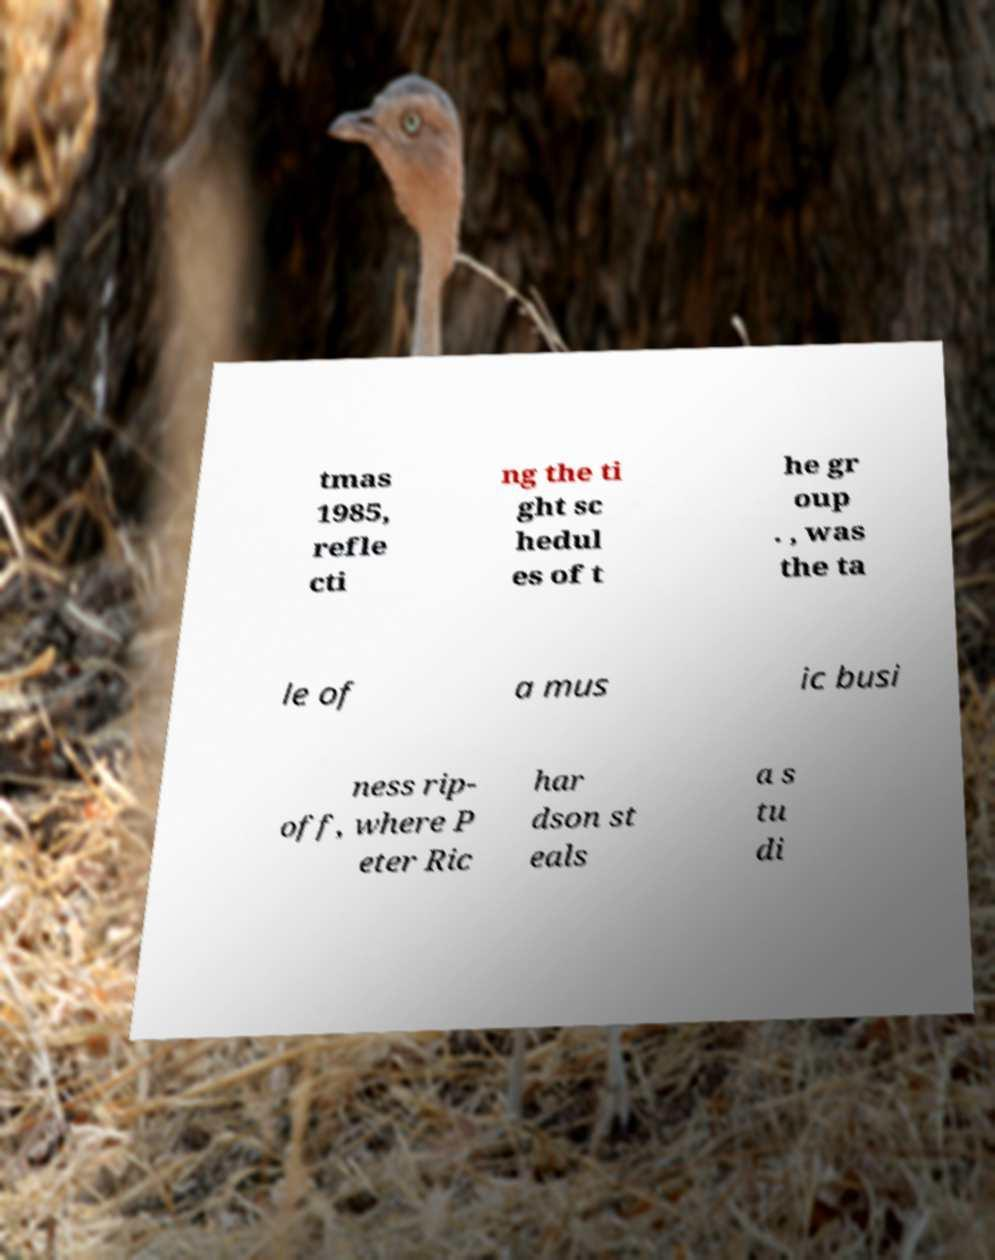Please identify and transcribe the text found in this image. tmas 1985, refle cti ng the ti ght sc hedul es of t he gr oup . , was the ta le of a mus ic busi ness rip- off, where P eter Ric har dson st eals a s tu di 